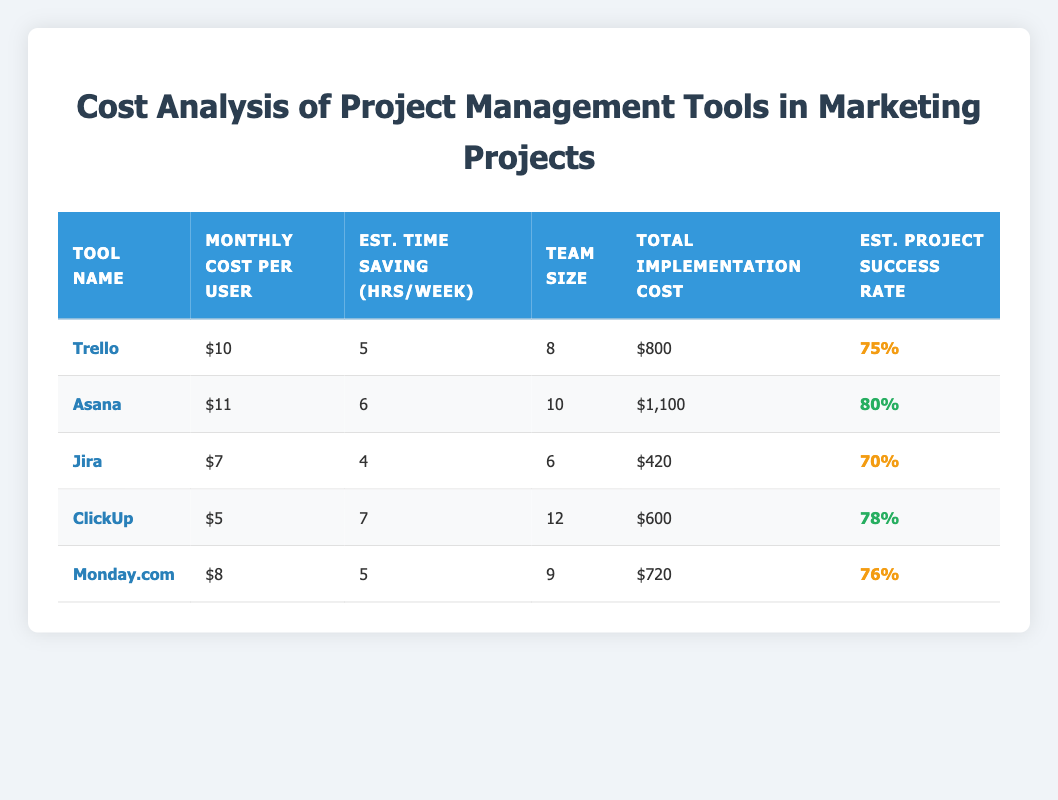What is the monthly cost per user for Asana? The monthly cost per user for Asana is directly listed in the table under the column "Monthly Cost per User." It shows $11.
Answer: 11 Which tool has the highest estimated project success rate? By checking the "Estimated Project Success Rate" column, Asana has the highest rate at 80%.
Answer: Asana What is the total implementation cost for ClickUp? The total implementation cost for ClickUp is shown directly in the table under "Total Implementation Cost," which is $600.
Answer: 600 What is the average monthly cost per user for all tools? The monthly costs are $10 (Trello), $11 (Asana), $7 (Jira), $5 (ClickUp), and $8 (Monday.com). The total is 10 + 11 + 7 + 5 + 8 = 41. The average is 41/5 = 8.2.
Answer: 8.2 Which tool offers the most estimated time savings per week? Checking the "Est. Time Saving (hrs/week)" column, ClickUp offers the most at 7 hours per week.
Answer: ClickUp Do all tools have an estimated project success rate of at least 70%? By reviewing the "Estimated Project Success Rate" for each tool, Trello (75%), Asana (80%), Jira (70%), ClickUp (78%), and Monday.com (76%) all meet the 70% threshold.
Answer: Yes How many total hours are saved per week across the entire team for Jira? The estimated time savings per week for Jira is 4 hours. With a team size of 6, total hours saved per week is 4 hours * 6 members = 24 hours.
Answer: 24 Which tool has the lowest total implementation cost and what is that cost? From the "Total Implementation Cost" column, Jira has the lowest cost of $420.
Answer: 420 If you implement Trello, what would the total monthly cost for the entire team be? The monthly cost per user for Trello is $10, and with a team size of 8, the total monthly cost is 10 * 8 = $80.
Answer: 80 